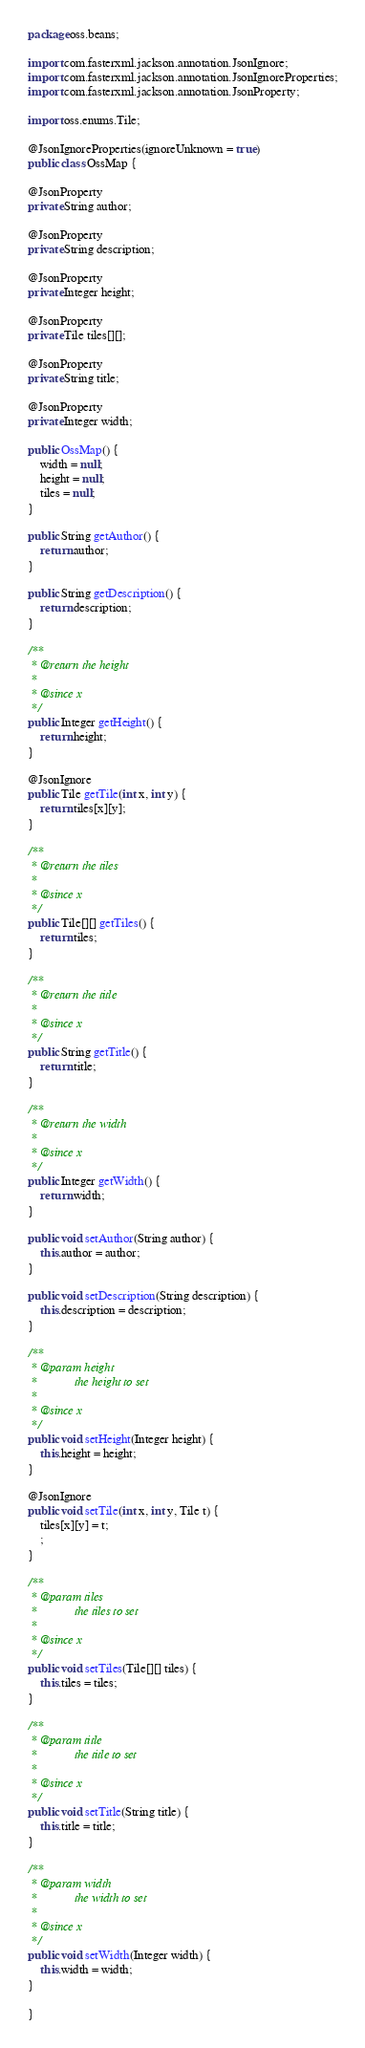<code> <loc_0><loc_0><loc_500><loc_500><_Java_>package oss.beans;

import com.fasterxml.jackson.annotation.JsonIgnore;
import com.fasterxml.jackson.annotation.JsonIgnoreProperties;
import com.fasterxml.jackson.annotation.JsonProperty;

import oss.enums.Tile;

@JsonIgnoreProperties(ignoreUnknown = true)
public class OssMap {

@JsonProperty
private String author;

@JsonProperty
private String description;

@JsonProperty
private Integer height;

@JsonProperty
private Tile tiles[][];

@JsonProperty
private String title;

@JsonProperty
private Integer width;

public OssMap() {
	width = null;
	height = null;
	tiles = null;
}

public String getAuthor() {
	return author;
}

public String getDescription() {
	return description;
}

/**
 * @return the height
 *
 * @since x
 */
public Integer getHeight() {
	return height;
}

@JsonIgnore
public Tile getTile(int x, int y) {
	return tiles[x][y];
}

/**
 * @return the tiles
 *
 * @since x
 */
public Tile[][] getTiles() {
	return tiles;
}

/**
 * @return the title
 *
 * @since x
 */
public String getTitle() {
	return title;
}

/**
 * @return the width
 *
 * @since x
 */
public Integer getWidth() {
	return width;
}

public void setAuthor(String author) {
	this.author = author;
}

public void setDescription(String description) {
	this.description = description;
}

/**
 * @param height
 *            the height to set
 *
 * @since x
 */
public void setHeight(Integer height) {
	this.height = height;
}

@JsonIgnore
public void setTile(int x, int y, Tile t) {
	tiles[x][y] = t;
	;
}

/**
 * @param tiles
 *            the tiles to set
 *
 * @since x
 */
public void setTiles(Tile[][] tiles) {
	this.tiles = tiles;
}

/**
 * @param title
 *            the title to set
 *
 * @since x
 */
public void setTitle(String title) {
	this.title = title;
}

/**
 * @param width
 *            the width to set
 *
 * @since x
 */
public void setWidth(Integer width) {
	this.width = width;
}

}
</code> 